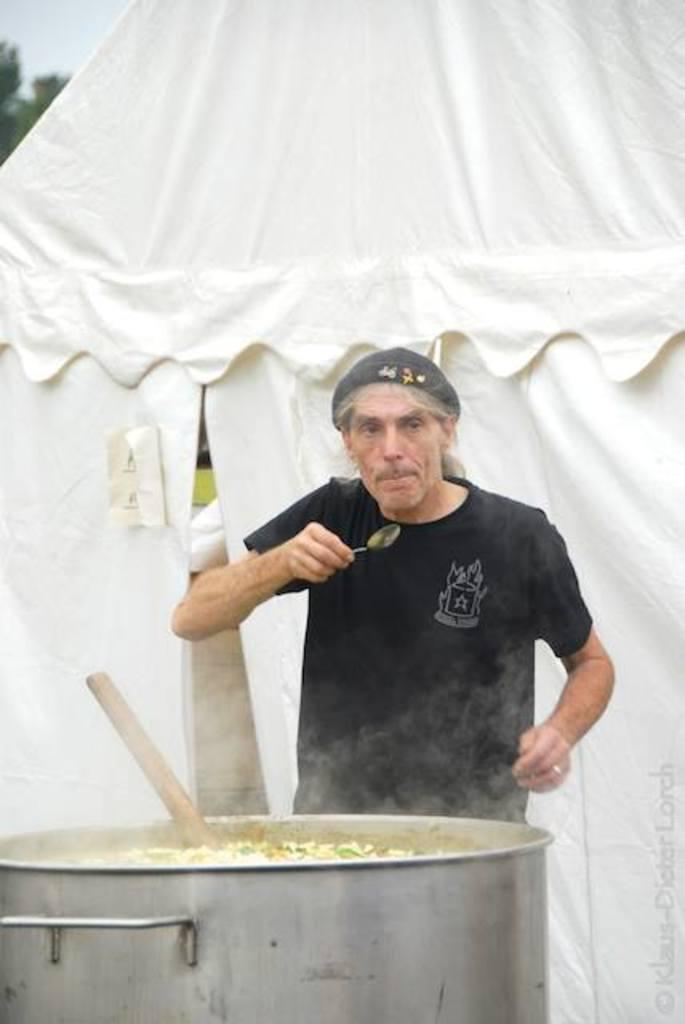What is the person in the image holding? The person is holding a spoon in the image. What is in the big bowl that can be seen in the image? There is food in the big bowl in the image. What type of natural environment is visible in the image? Trees and the sky are visible in the image. How would you describe the overall color tone of the image? There is a white color tint in the image. What type of cheese is being used as a yoke for the rings in the image? There is no cheese, yoke, or rings present in the image. 